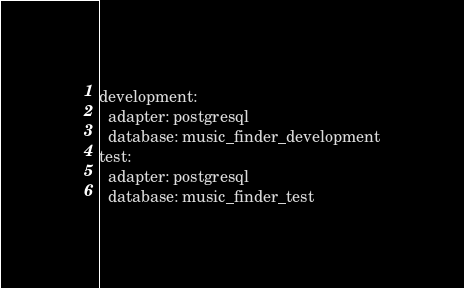Convert code to text. <code><loc_0><loc_0><loc_500><loc_500><_YAML_>development:
  adapter: postgresql
  database: music_finder_development
test:
  adapter: postgresql
  database: music_finder_test
</code> 